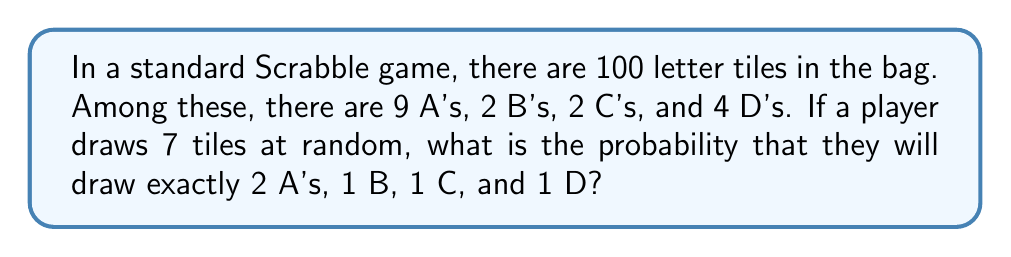Can you answer this question? To solve this problem, we'll use the concept of hypergeometric distribution and the multiplication principle. Let's break it down step-by-step:

1) First, we need to calculate the probability of drawing each set of tiles:

   a) Probability of drawing exactly 2 A's out of 9 from 7 draws:
      $$P(2A) = \frac{\binom{9}{2} \binom{91}{5}}{\binom{100}{7}}$$

   b) Probability of drawing exactly 1 B out of 2 from the remaining 5 draws:
      $$P(1B) = \frac{\binom{2}{1} \binom{89}{4}}{\binom{91}{5}}$$

   c) Probability of drawing exactly 1 C out of 2 from the remaining 4 draws:
      $$P(1C) = \frac{\binom{2}{1} \binom{87}{3}}{\binom{89}{4}}$$

   d) Probability of drawing exactly 1 D out of 4 from the remaining 3 draws:
      $$P(1D) = \frac{\binom{4}{1} \binom{83}{2}}{\binom{87}{3}}$$

2) The probability of all these events occurring together is the product of their individual probabilities:

   $$P(\text{2A, 1B, 1C, 1D}) = P(2A) \times P(1B) \times P(1C) \times P(1D)$$

3) Let's calculate each probability:

   $$P(2A) = \frac{36 \times 2,245,940}{16,007,560} = \frac{80,853,840}{16,007,560}$$

   $$P(1B) = \frac{2 \times 3,024,305}{2,245,940} = \frac{6,048,610}{2,245,940}$$

   $$P(1C) = \frac{2 \times 1,184,040}{3,024,305} = \frac{2,368,080}{3,024,305}$$

   $$P(1D) = \frac{4 \times 3,403}{1,184,040} = \frac{13,612}{1,184,040}$$

4) Multiplying these probabilities:

   $$P(\text{2A, 1B, 1C, 1D}) = \frac{80,853,840}{16,007,560} \times \frac{6,048,610}{2,245,940} \times \frac{2,368,080}{3,024,305} \times \frac{13,612}{1,184,040}$$

5) Simplifying:

   $$P(\text{2A, 1B, 1C, 1D}) = \frac{80,853,840 \times 6,048,610 \times 2,368,080 \times 13,612}{16,007,560 \times 2,245,940 \times 3,024,305 \times 1,184,040} \approx 0.000323$$
Answer: The probability of drawing exactly 2 A's, 1 B, 1 C, and 1 D when drawing 7 tiles from a standard Scrabble bag is approximately 0.000323 or about 0.0323%. 